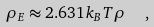Convert formula to latex. <formula><loc_0><loc_0><loc_500><loc_500>\rho _ { E } \approx 2 . 6 3 1 k _ { B } T \rho \ \ ,</formula> 